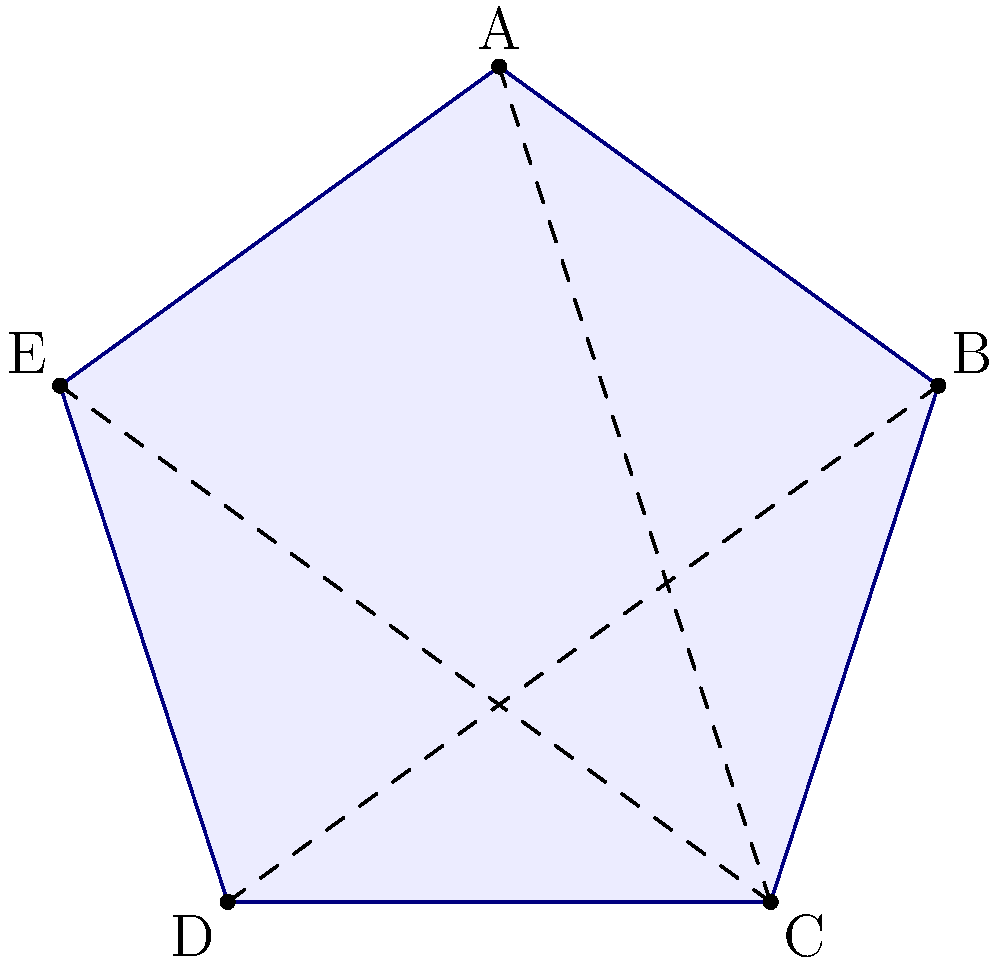Consider the symmetries of a regular pentagon, as shown in the figure above. How many elements are in the symmetry group of this pentagon? (Note: This concept is relevant to crystallography, which is important in materials science and engineering, fields that are advancing rapidly in Ghana's growing industrial sector.) Let's approach this step-by-step:

1) The symmetry group of a regular pentagon includes rotations and reflections.

2) Rotations:
   - There are 5 rotational symmetries (including the identity rotation):
     $$0°, 72°, 144°, 216°, 288°$$

3) Reflections:
   - There are 5 lines of reflection, one through each vertex to the midpoint of the opposite side.

4) Counting the elements:
   - 5 rotations (including identity)
   - 5 reflections

5) Total number of symmetries:
   $$5 + 5 = 10$$

Thus, the symmetry group of a regular pentagon has 10 elements.

This group is known as the dihedral group $D_5$, which is important in various fields including crystallography and molecular symmetry, areas of potential interest for engineering and science programs in Ghanaian universities.
Answer: 10 